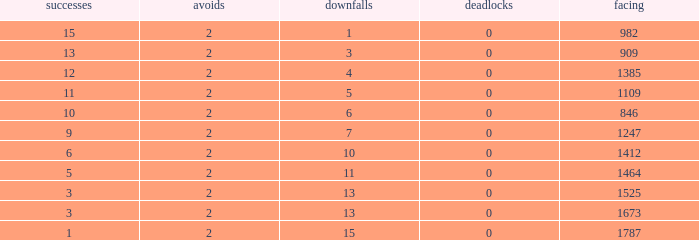What is the average number of Byes when there were less than 0 losses and were against 1247? None. 